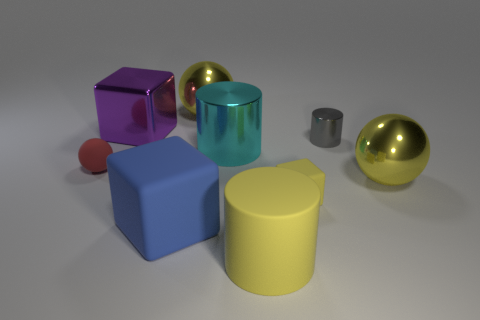There is a matte cylinder; is it the same color as the rubber block that is behind the big blue cube?
Offer a very short reply. Yes. Is the number of large spheres that are left of the purple metallic block less than the number of cyan shiny things?
Your answer should be very brief. Yes. What number of small blocks are there?
Make the answer very short. 1. There is a large yellow metallic object that is left of the large yellow ball that is to the right of the large cyan thing; what shape is it?
Provide a succinct answer. Sphere. How many big metal balls are on the left side of the large cyan cylinder?
Offer a terse response. 1. Do the tiny yellow block and the small object that is on the left side of the big rubber cylinder have the same material?
Offer a terse response. Yes. Are there any blue things that have the same size as the yellow rubber cylinder?
Make the answer very short. Yes. Is the number of objects on the right side of the tiny gray shiny object the same as the number of big cyan objects?
Keep it short and to the point. Yes. How big is the gray cylinder?
Offer a terse response. Small. How many big metal things are on the right side of the shiny cylinder left of the big yellow matte object?
Give a very brief answer. 1. 